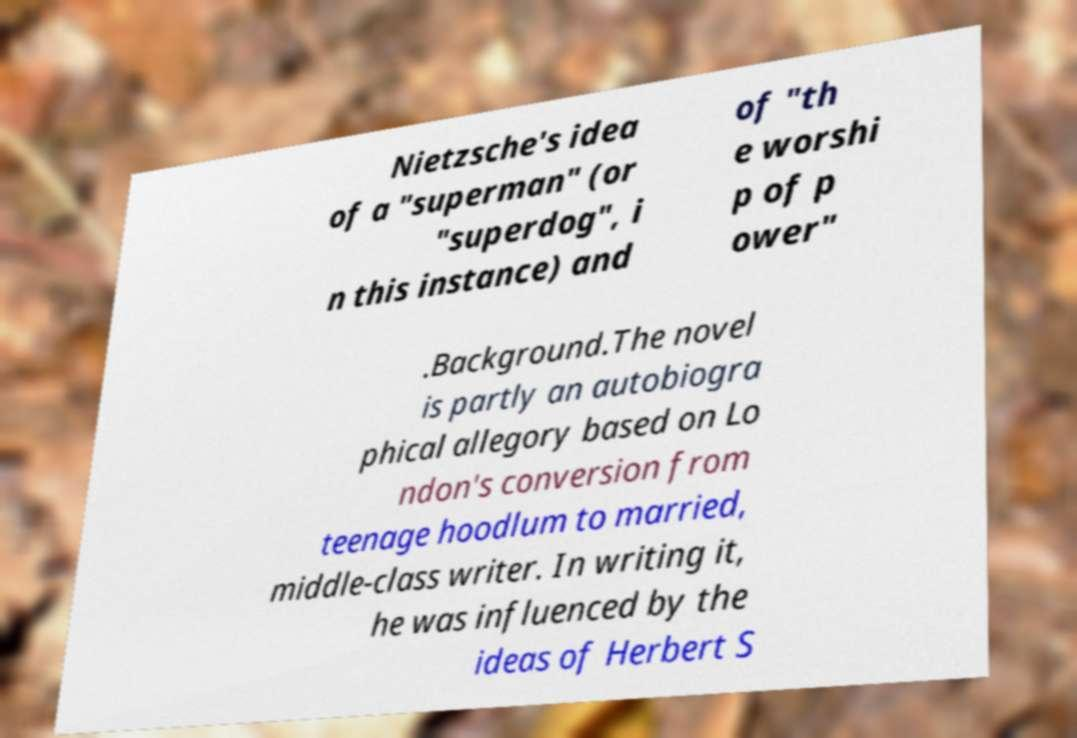Can you accurately transcribe the text from the provided image for me? Nietzsche's idea of a "superman" (or "superdog", i n this instance) and of "th e worshi p of p ower" .Background.The novel is partly an autobiogra phical allegory based on Lo ndon's conversion from teenage hoodlum to married, middle-class writer. In writing it, he was influenced by the ideas of Herbert S 